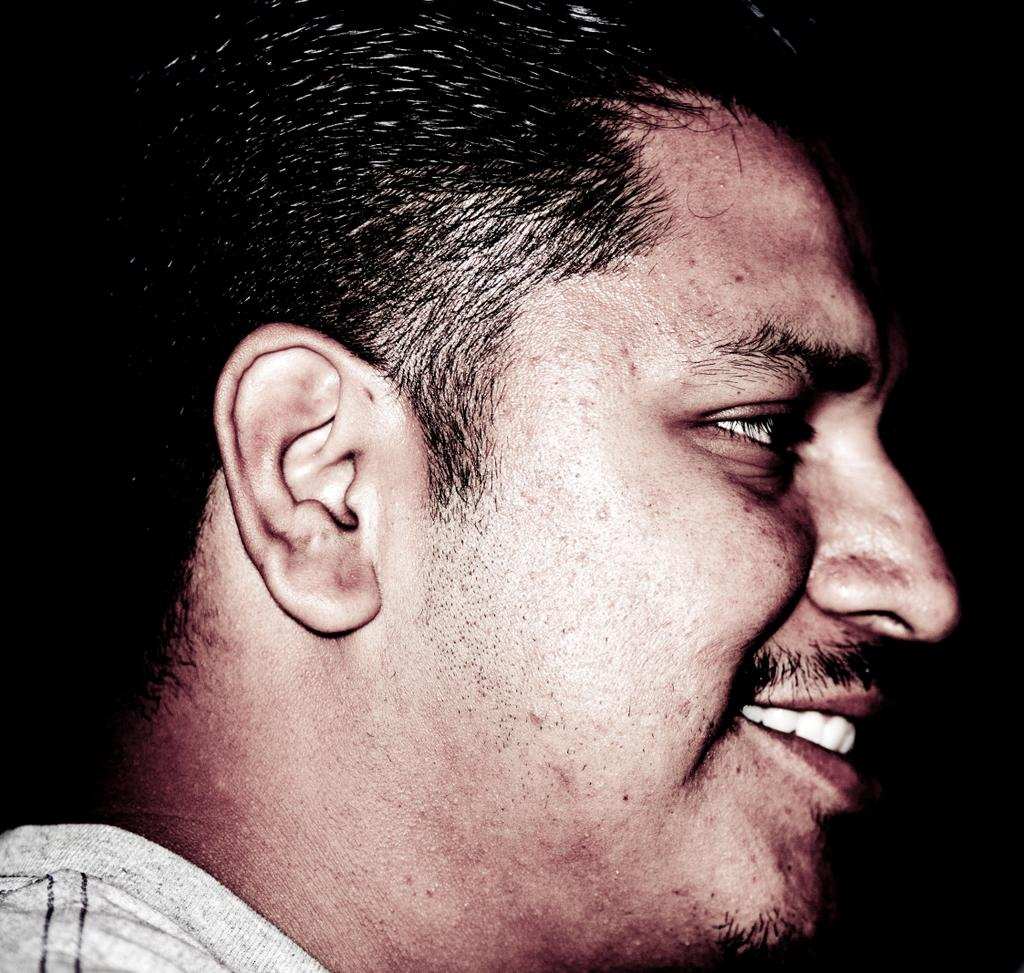Who is present in the image? There is a man in the image. What is the man doing in the image? The man is smiling in the image. What color is the background of the image? The background of the image is black. What type of pet is the man holding in the image? There is no pet present in the image; the man is simply smiling. What is the man using to kick a ball in the image? There is no ball or kicking action in the image; the man is just smiling. 